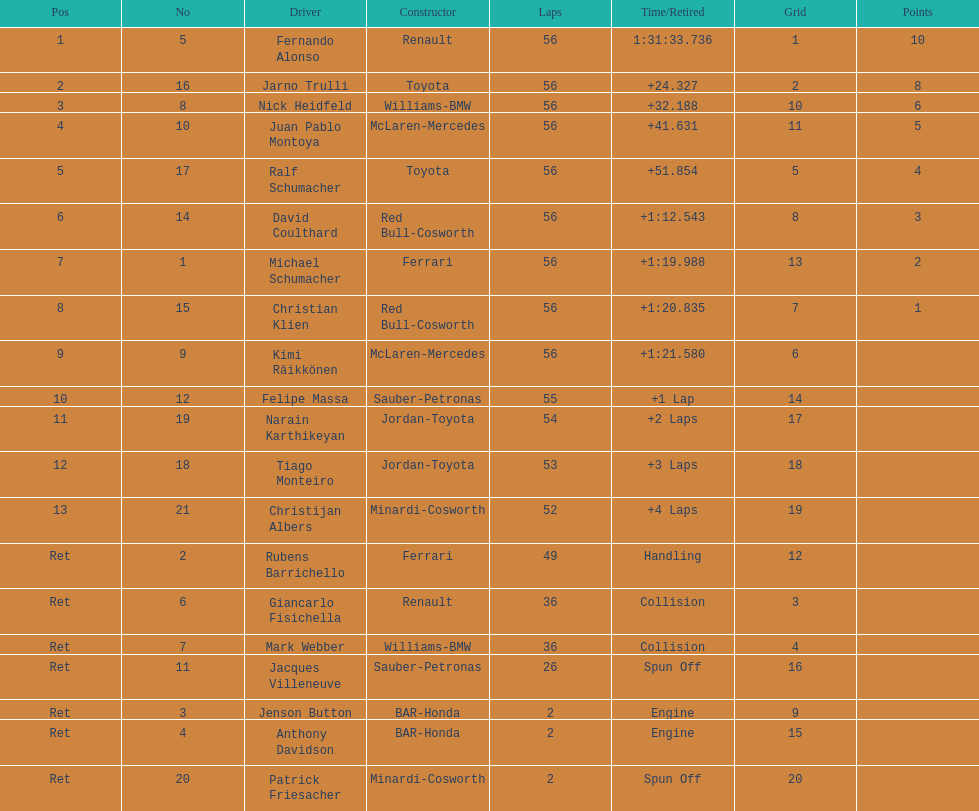What were the total number of laps completed by the 1st position winner? 56. 